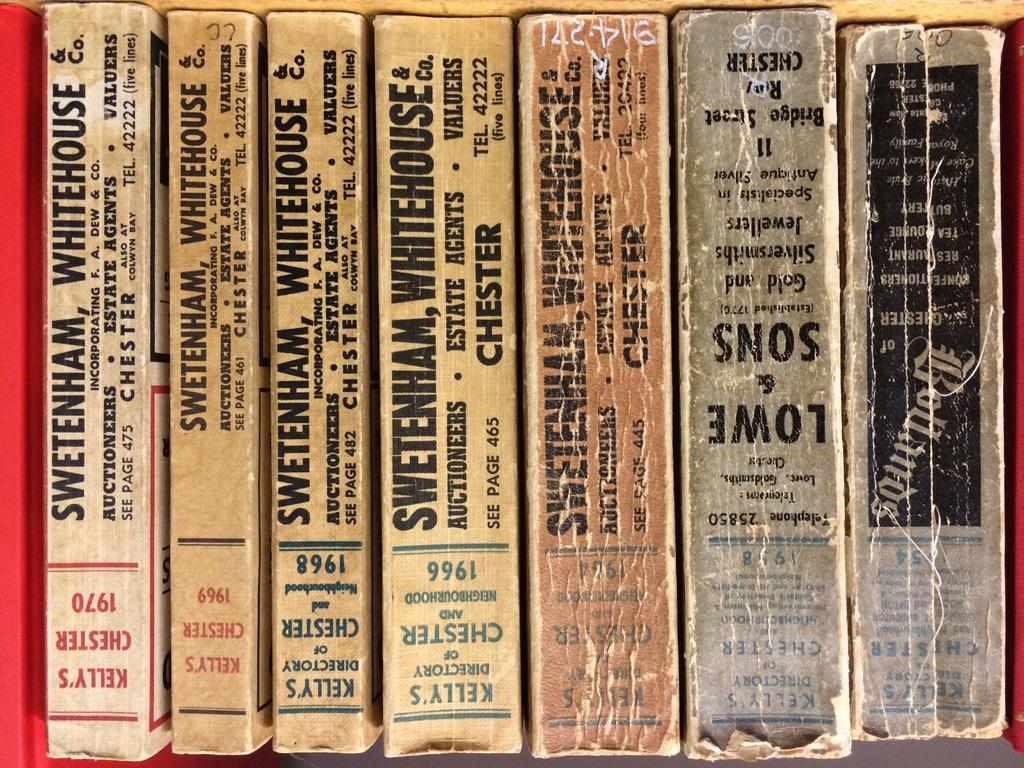<image>
Share a concise interpretation of the image provided. The binders of a few old books date to the 1960's and 1970's. 